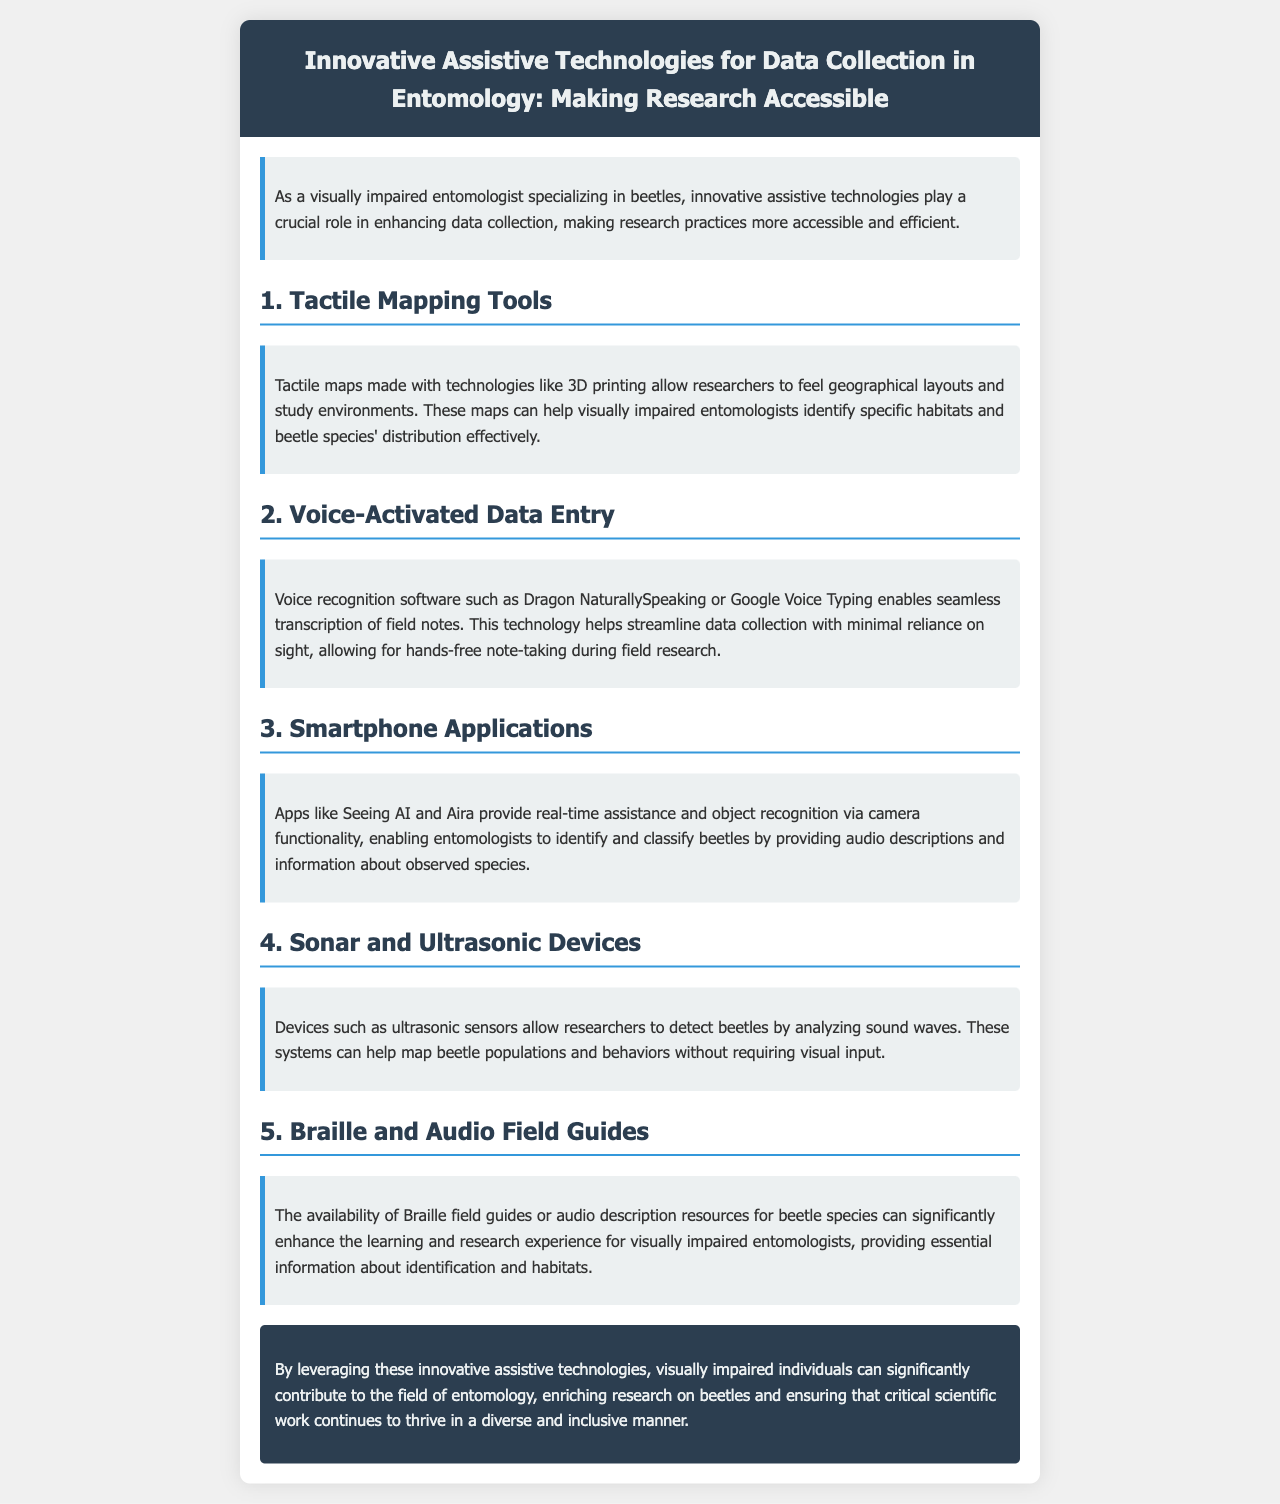What is the main focus of the brochure? The main focus of the brochure is on assistive technologies for data collection in entomology, specifically for visually impaired researchers.
Answer: Assistive technologies for data collection in entomology What is one innovative technology mentioned for helping visually impaired entomologists? The document lists several technologies, including tactile mapping tools, which allow researchers to feel geographical layouts.
Answer: Tactile mapping tools Which voice recognition software is highlighted in the brochure? The brochure specifically names Dragon NaturallySpeaking and Google Voice Typing as examples of voice recognition software.
Answer: Dragon NaturallySpeaking How do smartphone applications assist entomologists? The document states that apps like Seeing AI and Aira provide real-time assistance and object recognition via audio descriptions.
Answer: Real-time assistance and object recognition What is one function of sonar and ultrasonic devices mentioned? The brochure explains that these devices allow researchers to detect beetles by analyzing sound waves.
Answer: Detect beetles using sound waves Which type of guides enhances learning for visually impaired entomologists? The document highlights the importance of Braille and audio field guides for providing essential identification information.
Answer: Braille and audio field guides How do voice-activated data entry systems improve field research? These systems streamline data collection with minimal reliance on sight, allowing hands-free note-taking.
Answer: Hands-free note-taking What does the conclusion emphasize about visually impaired individuals in entomology? The conclusion emphasizes that by leveraging these technologies, visually impaired individuals can contribute significantly to entomology.
Answer: Significant contribution 